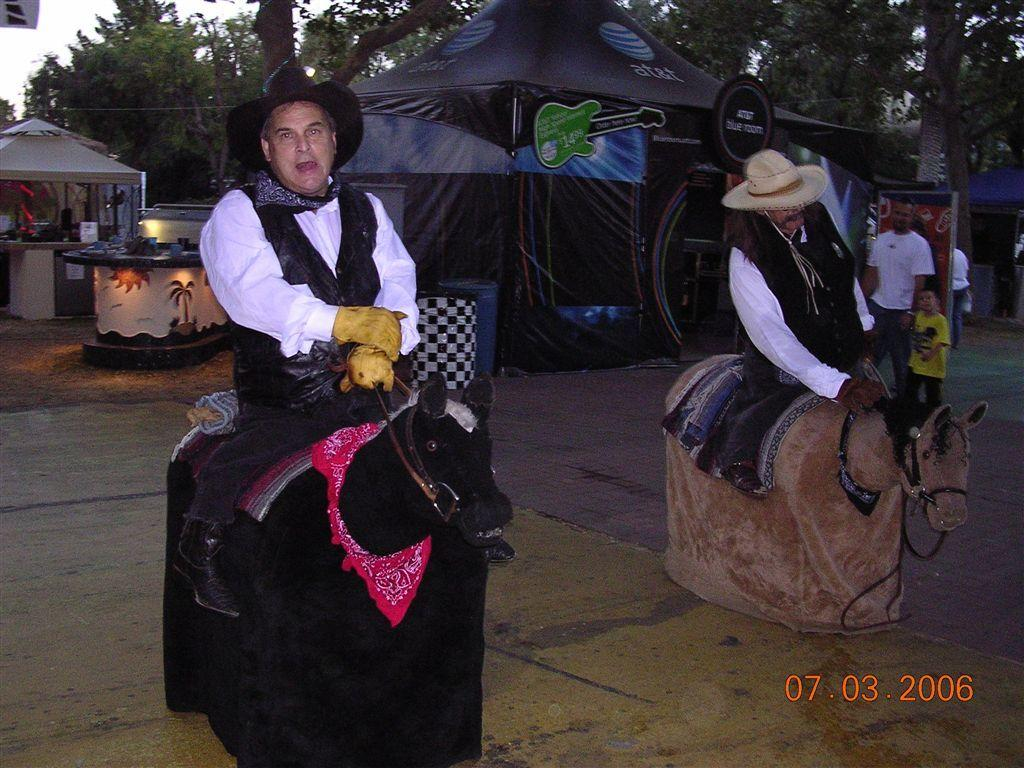What are the two people sitting on in the image? The two people are sitting on toy horses. What can be seen on the road in the image? There are people on the road in the image. What type of structures are present in the image? There are stalls in the image. What decorative elements are visible in the image? There are banners in the image. What natural elements can be seen in the background of the image? There are trees visible in the background of the image. Where is the kitten playing with the gate in the image? There is no kitten or gate present in the image. What type of van can be seen parked near the stalls in the image? There is no van present in the image; only the two people on toy horses, people on the road, stalls, banners, and trees in the background are visible. 